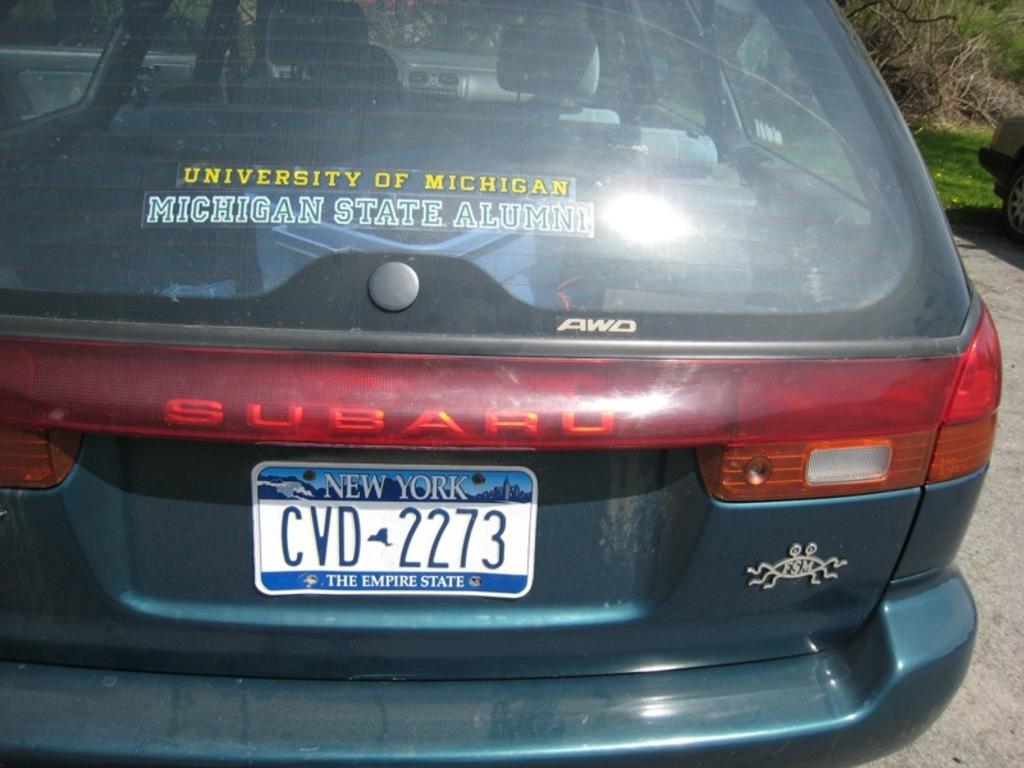What state is on the plate?
Ensure brevity in your answer.  New york. 